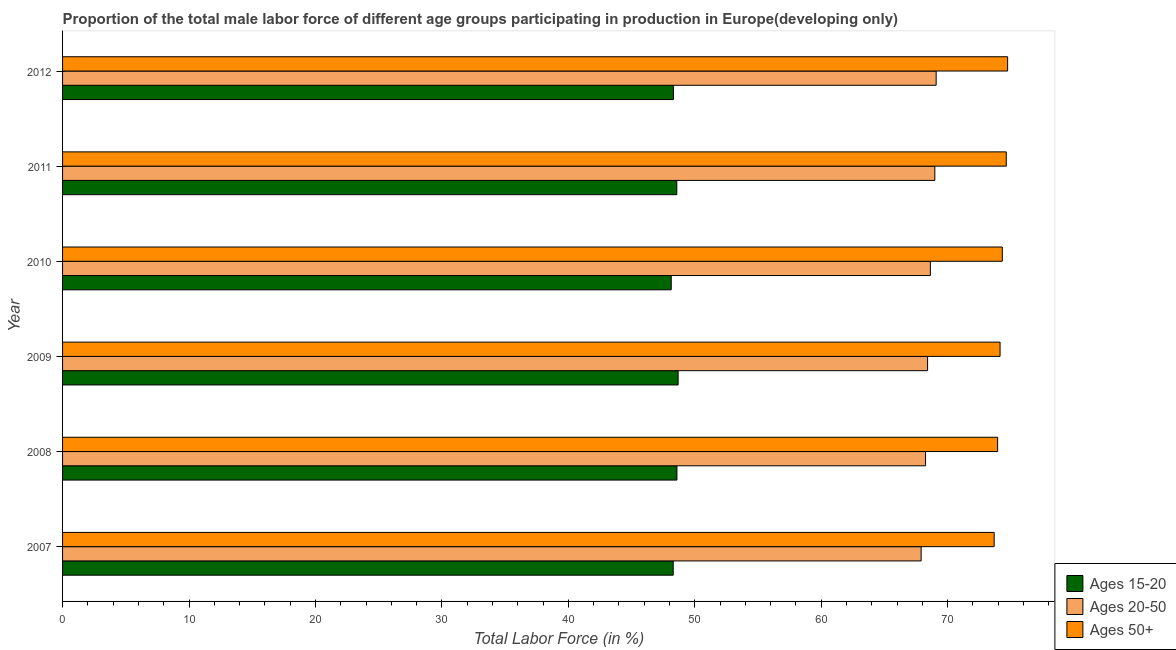How many groups of bars are there?
Your answer should be compact. 6. How many bars are there on the 1st tick from the top?
Provide a short and direct response. 3. What is the percentage of male labor force above age 50 in 2011?
Ensure brevity in your answer.  74.63. Across all years, what is the maximum percentage of male labor force above age 50?
Make the answer very short. 74.74. Across all years, what is the minimum percentage of male labor force within the age group 20-50?
Offer a terse response. 67.9. In which year was the percentage of male labor force above age 50 maximum?
Your response must be concise. 2012. In which year was the percentage of male labor force within the age group 15-20 minimum?
Make the answer very short. 2010. What is the total percentage of male labor force within the age group 15-20 in the graph?
Your response must be concise. 290.58. What is the difference between the percentage of male labor force within the age group 20-50 in 2007 and that in 2009?
Your answer should be very brief. -0.51. What is the difference between the percentage of male labor force within the age group 15-20 in 2007 and the percentage of male labor force within the age group 20-50 in 2012?
Offer a very short reply. -20.79. What is the average percentage of male labor force within the age group 20-50 per year?
Keep it short and to the point. 68.54. In the year 2007, what is the difference between the percentage of male labor force above age 50 and percentage of male labor force within the age group 20-50?
Your answer should be compact. 5.78. Is the difference between the percentage of male labor force within the age group 15-20 in 2007 and 2010 greater than the difference between the percentage of male labor force above age 50 in 2007 and 2010?
Your answer should be compact. Yes. What is the difference between the highest and the second highest percentage of male labor force within the age group 15-20?
Provide a succinct answer. 0.1. What is the difference between the highest and the lowest percentage of male labor force within the age group 20-50?
Make the answer very short. 1.19. In how many years, is the percentage of male labor force within the age group 20-50 greater than the average percentage of male labor force within the age group 20-50 taken over all years?
Offer a terse response. 3. What does the 1st bar from the top in 2012 represents?
Ensure brevity in your answer.  Ages 50+. What does the 2nd bar from the bottom in 2010 represents?
Your answer should be very brief. Ages 20-50. Is it the case that in every year, the sum of the percentage of male labor force within the age group 15-20 and percentage of male labor force within the age group 20-50 is greater than the percentage of male labor force above age 50?
Make the answer very short. Yes. How many bars are there?
Keep it short and to the point. 18. Are all the bars in the graph horizontal?
Your answer should be compact. Yes. How many years are there in the graph?
Your answer should be compact. 6. Does the graph contain any zero values?
Provide a succinct answer. No. Does the graph contain grids?
Provide a succinct answer. No. What is the title of the graph?
Provide a short and direct response. Proportion of the total male labor force of different age groups participating in production in Europe(developing only). What is the Total Labor Force (in %) of Ages 15-20 in 2007?
Your response must be concise. 48.29. What is the Total Labor Force (in %) of Ages 20-50 in 2007?
Provide a short and direct response. 67.9. What is the Total Labor Force (in %) of Ages 50+ in 2007?
Give a very brief answer. 73.68. What is the Total Labor Force (in %) of Ages 15-20 in 2008?
Offer a very short reply. 48.59. What is the Total Labor Force (in %) in Ages 20-50 in 2008?
Your response must be concise. 68.25. What is the Total Labor Force (in %) of Ages 50+ in 2008?
Your answer should be compact. 73.95. What is the Total Labor Force (in %) of Ages 15-20 in 2009?
Offer a very short reply. 48.68. What is the Total Labor Force (in %) of Ages 20-50 in 2009?
Make the answer very short. 68.41. What is the Total Labor Force (in %) in Ages 50+ in 2009?
Provide a short and direct response. 74.14. What is the Total Labor Force (in %) of Ages 15-20 in 2010?
Keep it short and to the point. 48.14. What is the Total Labor Force (in %) in Ages 20-50 in 2010?
Make the answer very short. 68.63. What is the Total Labor Force (in %) in Ages 50+ in 2010?
Keep it short and to the point. 74.32. What is the Total Labor Force (in %) in Ages 15-20 in 2011?
Offer a very short reply. 48.58. What is the Total Labor Force (in %) in Ages 20-50 in 2011?
Make the answer very short. 68.98. What is the Total Labor Force (in %) in Ages 50+ in 2011?
Your answer should be very brief. 74.63. What is the Total Labor Force (in %) in Ages 15-20 in 2012?
Provide a succinct answer. 48.31. What is the Total Labor Force (in %) in Ages 20-50 in 2012?
Offer a terse response. 69.09. What is the Total Labor Force (in %) of Ages 50+ in 2012?
Offer a terse response. 74.74. Across all years, what is the maximum Total Labor Force (in %) of Ages 15-20?
Make the answer very short. 48.68. Across all years, what is the maximum Total Labor Force (in %) of Ages 20-50?
Offer a terse response. 69.09. Across all years, what is the maximum Total Labor Force (in %) in Ages 50+?
Provide a succinct answer. 74.74. Across all years, what is the minimum Total Labor Force (in %) of Ages 15-20?
Make the answer very short. 48.14. Across all years, what is the minimum Total Labor Force (in %) of Ages 20-50?
Make the answer very short. 67.9. Across all years, what is the minimum Total Labor Force (in %) in Ages 50+?
Provide a short and direct response. 73.68. What is the total Total Labor Force (in %) of Ages 15-20 in the graph?
Offer a very short reply. 290.58. What is the total Total Labor Force (in %) of Ages 20-50 in the graph?
Offer a very short reply. 411.26. What is the total Total Labor Force (in %) in Ages 50+ in the graph?
Provide a short and direct response. 445.46. What is the difference between the Total Labor Force (in %) of Ages 15-20 in 2007 and that in 2008?
Provide a succinct answer. -0.29. What is the difference between the Total Labor Force (in %) of Ages 20-50 in 2007 and that in 2008?
Provide a succinct answer. -0.35. What is the difference between the Total Labor Force (in %) of Ages 50+ in 2007 and that in 2008?
Your answer should be very brief. -0.27. What is the difference between the Total Labor Force (in %) of Ages 15-20 in 2007 and that in 2009?
Your answer should be compact. -0.39. What is the difference between the Total Labor Force (in %) in Ages 20-50 in 2007 and that in 2009?
Your response must be concise. -0.51. What is the difference between the Total Labor Force (in %) in Ages 50+ in 2007 and that in 2009?
Your answer should be compact. -0.47. What is the difference between the Total Labor Force (in %) of Ages 15-20 in 2007 and that in 2010?
Give a very brief answer. 0.16. What is the difference between the Total Labor Force (in %) of Ages 20-50 in 2007 and that in 2010?
Provide a succinct answer. -0.73. What is the difference between the Total Labor Force (in %) of Ages 50+ in 2007 and that in 2010?
Offer a terse response. -0.64. What is the difference between the Total Labor Force (in %) of Ages 15-20 in 2007 and that in 2011?
Your answer should be very brief. -0.28. What is the difference between the Total Labor Force (in %) in Ages 20-50 in 2007 and that in 2011?
Your answer should be compact. -1.08. What is the difference between the Total Labor Force (in %) of Ages 50+ in 2007 and that in 2011?
Your answer should be compact. -0.96. What is the difference between the Total Labor Force (in %) in Ages 15-20 in 2007 and that in 2012?
Ensure brevity in your answer.  -0.02. What is the difference between the Total Labor Force (in %) of Ages 20-50 in 2007 and that in 2012?
Make the answer very short. -1.19. What is the difference between the Total Labor Force (in %) of Ages 50+ in 2007 and that in 2012?
Your answer should be very brief. -1.06. What is the difference between the Total Labor Force (in %) of Ages 15-20 in 2008 and that in 2009?
Offer a terse response. -0.09. What is the difference between the Total Labor Force (in %) in Ages 20-50 in 2008 and that in 2009?
Your response must be concise. -0.16. What is the difference between the Total Labor Force (in %) in Ages 50+ in 2008 and that in 2009?
Provide a succinct answer. -0.19. What is the difference between the Total Labor Force (in %) of Ages 15-20 in 2008 and that in 2010?
Keep it short and to the point. 0.45. What is the difference between the Total Labor Force (in %) in Ages 20-50 in 2008 and that in 2010?
Make the answer very short. -0.38. What is the difference between the Total Labor Force (in %) of Ages 50+ in 2008 and that in 2010?
Offer a very short reply. -0.37. What is the difference between the Total Labor Force (in %) of Ages 15-20 in 2008 and that in 2011?
Give a very brief answer. 0.01. What is the difference between the Total Labor Force (in %) in Ages 20-50 in 2008 and that in 2011?
Offer a terse response. -0.73. What is the difference between the Total Labor Force (in %) in Ages 50+ in 2008 and that in 2011?
Ensure brevity in your answer.  -0.68. What is the difference between the Total Labor Force (in %) in Ages 15-20 in 2008 and that in 2012?
Offer a terse response. 0.28. What is the difference between the Total Labor Force (in %) of Ages 20-50 in 2008 and that in 2012?
Provide a succinct answer. -0.84. What is the difference between the Total Labor Force (in %) of Ages 50+ in 2008 and that in 2012?
Keep it short and to the point. -0.79. What is the difference between the Total Labor Force (in %) in Ages 15-20 in 2009 and that in 2010?
Your answer should be very brief. 0.55. What is the difference between the Total Labor Force (in %) in Ages 20-50 in 2009 and that in 2010?
Your answer should be compact. -0.22. What is the difference between the Total Labor Force (in %) of Ages 50+ in 2009 and that in 2010?
Offer a terse response. -0.18. What is the difference between the Total Labor Force (in %) in Ages 15-20 in 2009 and that in 2011?
Give a very brief answer. 0.11. What is the difference between the Total Labor Force (in %) in Ages 20-50 in 2009 and that in 2011?
Offer a very short reply. -0.57. What is the difference between the Total Labor Force (in %) in Ages 50+ in 2009 and that in 2011?
Give a very brief answer. -0.49. What is the difference between the Total Labor Force (in %) in Ages 15-20 in 2009 and that in 2012?
Give a very brief answer. 0.37. What is the difference between the Total Labor Force (in %) of Ages 20-50 in 2009 and that in 2012?
Provide a succinct answer. -0.68. What is the difference between the Total Labor Force (in %) in Ages 50+ in 2009 and that in 2012?
Your response must be concise. -0.6. What is the difference between the Total Labor Force (in %) in Ages 15-20 in 2010 and that in 2011?
Your response must be concise. -0.44. What is the difference between the Total Labor Force (in %) in Ages 20-50 in 2010 and that in 2011?
Offer a terse response. -0.35. What is the difference between the Total Labor Force (in %) of Ages 50+ in 2010 and that in 2011?
Keep it short and to the point. -0.31. What is the difference between the Total Labor Force (in %) of Ages 15-20 in 2010 and that in 2012?
Provide a succinct answer. -0.17. What is the difference between the Total Labor Force (in %) in Ages 20-50 in 2010 and that in 2012?
Give a very brief answer. -0.46. What is the difference between the Total Labor Force (in %) in Ages 50+ in 2010 and that in 2012?
Your response must be concise. -0.42. What is the difference between the Total Labor Force (in %) in Ages 15-20 in 2011 and that in 2012?
Your answer should be very brief. 0.27. What is the difference between the Total Labor Force (in %) of Ages 20-50 in 2011 and that in 2012?
Provide a short and direct response. -0.1. What is the difference between the Total Labor Force (in %) of Ages 50+ in 2011 and that in 2012?
Make the answer very short. -0.11. What is the difference between the Total Labor Force (in %) of Ages 15-20 in 2007 and the Total Labor Force (in %) of Ages 20-50 in 2008?
Your response must be concise. -19.96. What is the difference between the Total Labor Force (in %) of Ages 15-20 in 2007 and the Total Labor Force (in %) of Ages 50+ in 2008?
Offer a very short reply. -25.66. What is the difference between the Total Labor Force (in %) of Ages 20-50 in 2007 and the Total Labor Force (in %) of Ages 50+ in 2008?
Keep it short and to the point. -6.05. What is the difference between the Total Labor Force (in %) in Ages 15-20 in 2007 and the Total Labor Force (in %) in Ages 20-50 in 2009?
Offer a terse response. -20.12. What is the difference between the Total Labor Force (in %) of Ages 15-20 in 2007 and the Total Labor Force (in %) of Ages 50+ in 2009?
Offer a terse response. -25.85. What is the difference between the Total Labor Force (in %) in Ages 20-50 in 2007 and the Total Labor Force (in %) in Ages 50+ in 2009?
Your answer should be very brief. -6.24. What is the difference between the Total Labor Force (in %) of Ages 15-20 in 2007 and the Total Labor Force (in %) of Ages 20-50 in 2010?
Provide a succinct answer. -20.34. What is the difference between the Total Labor Force (in %) of Ages 15-20 in 2007 and the Total Labor Force (in %) of Ages 50+ in 2010?
Offer a terse response. -26.03. What is the difference between the Total Labor Force (in %) of Ages 20-50 in 2007 and the Total Labor Force (in %) of Ages 50+ in 2010?
Make the answer very short. -6.42. What is the difference between the Total Labor Force (in %) of Ages 15-20 in 2007 and the Total Labor Force (in %) of Ages 20-50 in 2011?
Keep it short and to the point. -20.69. What is the difference between the Total Labor Force (in %) in Ages 15-20 in 2007 and the Total Labor Force (in %) in Ages 50+ in 2011?
Give a very brief answer. -26.34. What is the difference between the Total Labor Force (in %) in Ages 20-50 in 2007 and the Total Labor Force (in %) in Ages 50+ in 2011?
Give a very brief answer. -6.73. What is the difference between the Total Labor Force (in %) in Ages 15-20 in 2007 and the Total Labor Force (in %) in Ages 20-50 in 2012?
Your response must be concise. -20.79. What is the difference between the Total Labor Force (in %) of Ages 15-20 in 2007 and the Total Labor Force (in %) of Ages 50+ in 2012?
Your response must be concise. -26.45. What is the difference between the Total Labor Force (in %) of Ages 20-50 in 2007 and the Total Labor Force (in %) of Ages 50+ in 2012?
Ensure brevity in your answer.  -6.84. What is the difference between the Total Labor Force (in %) of Ages 15-20 in 2008 and the Total Labor Force (in %) of Ages 20-50 in 2009?
Your answer should be very brief. -19.82. What is the difference between the Total Labor Force (in %) of Ages 15-20 in 2008 and the Total Labor Force (in %) of Ages 50+ in 2009?
Keep it short and to the point. -25.56. What is the difference between the Total Labor Force (in %) in Ages 20-50 in 2008 and the Total Labor Force (in %) in Ages 50+ in 2009?
Offer a very short reply. -5.89. What is the difference between the Total Labor Force (in %) of Ages 15-20 in 2008 and the Total Labor Force (in %) of Ages 20-50 in 2010?
Offer a terse response. -20.04. What is the difference between the Total Labor Force (in %) of Ages 15-20 in 2008 and the Total Labor Force (in %) of Ages 50+ in 2010?
Keep it short and to the point. -25.73. What is the difference between the Total Labor Force (in %) of Ages 20-50 in 2008 and the Total Labor Force (in %) of Ages 50+ in 2010?
Offer a very short reply. -6.07. What is the difference between the Total Labor Force (in %) of Ages 15-20 in 2008 and the Total Labor Force (in %) of Ages 20-50 in 2011?
Provide a short and direct response. -20.4. What is the difference between the Total Labor Force (in %) in Ages 15-20 in 2008 and the Total Labor Force (in %) in Ages 50+ in 2011?
Give a very brief answer. -26.05. What is the difference between the Total Labor Force (in %) in Ages 20-50 in 2008 and the Total Labor Force (in %) in Ages 50+ in 2011?
Provide a short and direct response. -6.38. What is the difference between the Total Labor Force (in %) of Ages 15-20 in 2008 and the Total Labor Force (in %) of Ages 20-50 in 2012?
Keep it short and to the point. -20.5. What is the difference between the Total Labor Force (in %) of Ages 15-20 in 2008 and the Total Labor Force (in %) of Ages 50+ in 2012?
Give a very brief answer. -26.15. What is the difference between the Total Labor Force (in %) of Ages 20-50 in 2008 and the Total Labor Force (in %) of Ages 50+ in 2012?
Offer a very short reply. -6.49. What is the difference between the Total Labor Force (in %) of Ages 15-20 in 2009 and the Total Labor Force (in %) of Ages 20-50 in 2010?
Offer a terse response. -19.95. What is the difference between the Total Labor Force (in %) of Ages 15-20 in 2009 and the Total Labor Force (in %) of Ages 50+ in 2010?
Your answer should be very brief. -25.64. What is the difference between the Total Labor Force (in %) in Ages 20-50 in 2009 and the Total Labor Force (in %) in Ages 50+ in 2010?
Your response must be concise. -5.91. What is the difference between the Total Labor Force (in %) in Ages 15-20 in 2009 and the Total Labor Force (in %) in Ages 20-50 in 2011?
Your answer should be very brief. -20.3. What is the difference between the Total Labor Force (in %) of Ages 15-20 in 2009 and the Total Labor Force (in %) of Ages 50+ in 2011?
Make the answer very short. -25.95. What is the difference between the Total Labor Force (in %) of Ages 20-50 in 2009 and the Total Labor Force (in %) of Ages 50+ in 2011?
Keep it short and to the point. -6.22. What is the difference between the Total Labor Force (in %) in Ages 15-20 in 2009 and the Total Labor Force (in %) in Ages 20-50 in 2012?
Make the answer very short. -20.41. What is the difference between the Total Labor Force (in %) in Ages 15-20 in 2009 and the Total Labor Force (in %) in Ages 50+ in 2012?
Your response must be concise. -26.06. What is the difference between the Total Labor Force (in %) of Ages 20-50 in 2009 and the Total Labor Force (in %) of Ages 50+ in 2012?
Keep it short and to the point. -6.33. What is the difference between the Total Labor Force (in %) of Ages 15-20 in 2010 and the Total Labor Force (in %) of Ages 20-50 in 2011?
Offer a very short reply. -20.85. What is the difference between the Total Labor Force (in %) of Ages 15-20 in 2010 and the Total Labor Force (in %) of Ages 50+ in 2011?
Offer a terse response. -26.5. What is the difference between the Total Labor Force (in %) in Ages 20-50 in 2010 and the Total Labor Force (in %) in Ages 50+ in 2011?
Your answer should be compact. -6. What is the difference between the Total Labor Force (in %) of Ages 15-20 in 2010 and the Total Labor Force (in %) of Ages 20-50 in 2012?
Offer a terse response. -20.95. What is the difference between the Total Labor Force (in %) in Ages 15-20 in 2010 and the Total Labor Force (in %) in Ages 50+ in 2012?
Give a very brief answer. -26.6. What is the difference between the Total Labor Force (in %) in Ages 20-50 in 2010 and the Total Labor Force (in %) in Ages 50+ in 2012?
Your response must be concise. -6.11. What is the difference between the Total Labor Force (in %) in Ages 15-20 in 2011 and the Total Labor Force (in %) in Ages 20-50 in 2012?
Your answer should be compact. -20.51. What is the difference between the Total Labor Force (in %) of Ages 15-20 in 2011 and the Total Labor Force (in %) of Ages 50+ in 2012?
Your answer should be compact. -26.16. What is the difference between the Total Labor Force (in %) in Ages 20-50 in 2011 and the Total Labor Force (in %) in Ages 50+ in 2012?
Offer a terse response. -5.76. What is the average Total Labor Force (in %) in Ages 15-20 per year?
Offer a very short reply. 48.43. What is the average Total Labor Force (in %) of Ages 20-50 per year?
Offer a very short reply. 68.54. What is the average Total Labor Force (in %) in Ages 50+ per year?
Your answer should be very brief. 74.24. In the year 2007, what is the difference between the Total Labor Force (in %) in Ages 15-20 and Total Labor Force (in %) in Ages 20-50?
Make the answer very short. -19.61. In the year 2007, what is the difference between the Total Labor Force (in %) of Ages 15-20 and Total Labor Force (in %) of Ages 50+?
Offer a very short reply. -25.38. In the year 2007, what is the difference between the Total Labor Force (in %) in Ages 20-50 and Total Labor Force (in %) in Ages 50+?
Keep it short and to the point. -5.78. In the year 2008, what is the difference between the Total Labor Force (in %) of Ages 15-20 and Total Labor Force (in %) of Ages 20-50?
Keep it short and to the point. -19.66. In the year 2008, what is the difference between the Total Labor Force (in %) in Ages 15-20 and Total Labor Force (in %) in Ages 50+?
Your response must be concise. -25.36. In the year 2008, what is the difference between the Total Labor Force (in %) in Ages 20-50 and Total Labor Force (in %) in Ages 50+?
Your answer should be very brief. -5.7. In the year 2009, what is the difference between the Total Labor Force (in %) of Ages 15-20 and Total Labor Force (in %) of Ages 20-50?
Make the answer very short. -19.73. In the year 2009, what is the difference between the Total Labor Force (in %) in Ages 15-20 and Total Labor Force (in %) in Ages 50+?
Offer a very short reply. -25.46. In the year 2009, what is the difference between the Total Labor Force (in %) of Ages 20-50 and Total Labor Force (in %) of Ages 50+?
Ensure brevity in your answer.  -5.73. In the year 2010, what is the difference between the Total Labor Force (in %) in Ages 15-20 and Total Labor Force (in %) in Ages 20-50?
Make the answer very short. -20.49. In the year 2010, what is the difference between the Total Labor Force (in %) in Ages 15-20 and Total Labor Force (in %) in Ages 50+?
Give a very brief answer. -26.18. In the year 2010, what is the difference between the Total Labor Force (in %) of Ages 20-50 and Total Labor Force (in %) of Ages 50+?
Give a very brief answer. -5.69. In the year 2011, what is the difference between the Total Labor Force (in %) of Ages 15-20 and Total Labor Force (in %) of Ages 20-50?
Your response must be concise. -20.41. In the year 2011, what is the difference between the Total Labor Force (in %) of Ages 15-20 and Total Labor Force (in %) of Ages 50+?
Provide a short and direct response. -26.06. In the year 2011, what is the difference between the Total Labor Force (in %) in Ages 20-50 and Total Labor Force (in %) in Ages 50+?
Your answer should be compact. -5.65. In the year 2012, what is the difference between the Total Labor Force (in %) in Ages 15-20 and Total Labor Force (in %) in Ages 20-50?
Provide a succinct answer. -20.78. In the year 2012, what is the difference between the Total Labor Force (in %) of Ages 15-20 and Total Labor Force (in %) of Ages 50+?
Make the answer very short. -26.43. In the year 2012, what is the difference between the Total Labor Force (in %) of Ages 20-50 and Total Labor Force (in %) of Ages 50+?
Offer a very short reply. -5.65. What is the ratio of the Total Labor Force (in %) of Ages 20-50 in 2007 to that in 2008?
Your answer should be very brief. 0.99. What is the ratio of the Total Labor Force (in %) of Ages 15-20 in 2007 to that in 2009?
Keep it short and to the point. 0.99. What is the ratio of the Total Labor Force (in %) in Ages 15-20 in 2007 to that in 2010?
Your response must be concise. 1. What is the ratio of the Total Labor Force (in %) in Ages 20-50 in 2007 to that in 2010?
Offer a terse response. 0.99. What is the ratio of the Total Labor Force (in %) of Ages 20-50 in 2007 to that in 2011?
Provide a short and direct response. 0.98. What is the ratio of the Total Labor Force (in %) in Ages 50+ in 2007 to that in 2011?
Keep it short and to the point. 0.99. What is the ratio of the Total Labor Force (in %) of Ages 20-50 in 2007 to that in 2012?
Offer a terse response. 0.98. What is the ratio of the Total Labor Force (in %) of Ages 50+ in 2007 to that in 2012?
Ensure brevity in your answer.  0.99. What is the ratio of the Total Labor Force (in %) of Ages 15-20 in 2008 to that in 2009?
Make the answer very short. 1. What is the ratio of the Total Labor Force (in %) of Ages 20-50 in 2008 to that in 2009?
Give a very brief answer. 1. What is the ratio of the Total Labor Force (in %) in Ages 50+ in 2008 to that in 2009?
Offer a terse response. 1. What is the ratio of the Total Labor Force (in %) of Ages 15-20 in 2008 to that in 2010?
Offer a terse response. 1.01. What is the ratio of the Total Labor Force (in %) of Ages 20-50 in 2008 to that in 2010?
Keep it short and to the point. 0.99. What is the ratio of the Total Labor Force (in %) in Ages 50+ in 2008 to that in 2010?
Your answer should be very brief. 0.99. What is the ratio of the Total Labor Force (in %) in Ages 15-20 in 2008 to that in 2011?
Keep it short and to the point. 1. What is the ratio of the Total Labor Force (in %) of Ages 20-50 in 2008 to that in 2011?
Offer a terse response. 0.99. What is the ratio of the Total Labor Force (in %) in Ages 50+ in 2008 to that in 2011?
Your answer should be compact. 0.99. What is the ratio of the Total Labor Force (in %) of Ages 15-20 in 2008 to that in 2012?
Offer a terse response. 1.01. What is the ratio of the Total Labor Force (in %) in Ages 20-50 in 2008 to that in 2012?
Your response must be concise. 0.99. What is the ratio of the Total Labor Force (in %) of Ages 15-20 in 2009 to that in 2010?
Provide a succinct answer. 1.01. What is the ratio of the Total Labor Force (in %) of Ages 20-50 in 2009 to that in 2010?
Your response must be concise. 1. What is the ratio of the Total Labor Force (in %) of Ages 15-20 in 2009 to that in 2011?
Ensure brevity in your answer.  1. What is the ratio of the Total Labor Force (in %) in Ages 50+ in 2009 to that in 2011?
Keep it short and to the point. 0.99. What is the ratio of the Total Labor Force (in %) in Ages 15-20 in 2009 to that in 2012?
Provide a succinct answer. 1.01. What is the ratio of the Total Labor Force (in %) in Ages 20-50 in 2009 to that in 2012?
Keep it short and to the point. 0.99. What is the ratio of the Total Labor Force (in %) in Ages 15-20 in 2010 to that in 2011?
Offer a very short reply. 0.99. What is the ratio of the Total Labor Force (in %) of Ages 20-50 in 2010 to that in 2011?
Ensure brevity in your answer.  0.99. What is the ratio of the Total Labor Force (in %) in Ages 20-50 in 2010 to that in 2012?
Make the answer very short. 0.99. What is the ratio of the Total Labor Force (in %) in Ages 20-50 in 2011 to that in 2012?
Make the answer very short. 1. What is the ratio of the Total Labor Force (in %) in Ages 50+ in 2011 to that in 2012?
Your answer should be compact. 1. What is the difference between the highest and the second highest Total Labor Force (in %) of Ages 15-20?
Provide a succinct answer. 0.09. What is the difference between the highest and the second highest Total Labor Force (in %) in Ages 20-50?
Provide a short and direct response. 0.1. What is the difference between the highest and the second highest Total Labor Force (in %) of Ages 50+?
Your answer should be very brief. 0.11. What is the difference between the highest and the lowest Total Labor Force (in %) in Ages 15-20?
Keep it short and to the point. 0.55. What is the difference between the highest and the lowest Total Labor Force (in %) in Ages 20-50?
Keep it short and to the point. 1.19. What is the difference between the highest and the lowest Total Labor Force (in %) in Ages 50+?
Your answer should be compact. 1.06. 